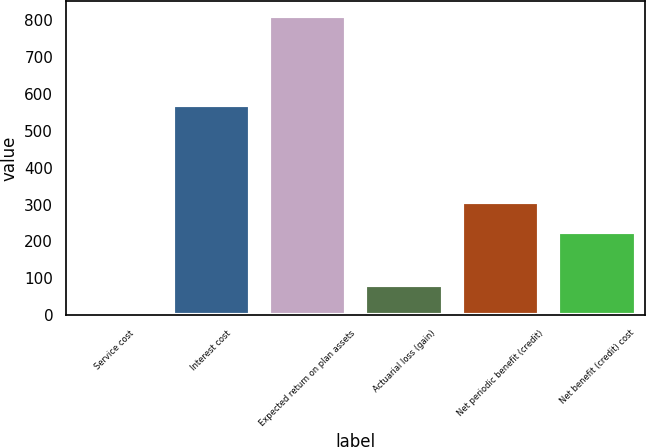Convert chart. <chart><loc_0><loc_0><loc_500><loc_500><bar_chart><fcel>Service cost<fcel>Interest cost<fcel>Expected return on plan assets<fcel>Actuarial loss (gain)<fcel>Net periodic benefit (credit)<fcel>Net benefit (credit) cost<nl><fcel>1<fcel>569<fcel>811<fcel>82<fcel>306<fcel>225<nl></chart> 